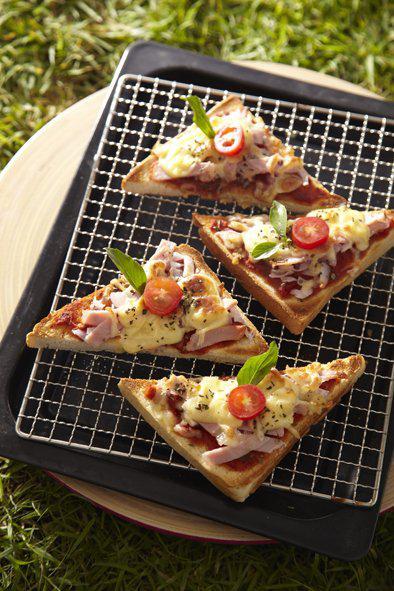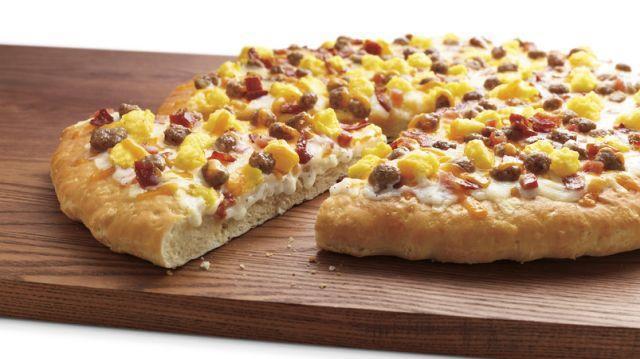The first image is the image on the left, the second image is the image on the right. Evaluate the accuracy of this statement regarding the images: "There is at least one uncut pizza.". Is it true? Answer yes or no. No. The first image is the image on the left, the second image is the image on the right. Analyze the images presented: Is the assertion "All the pizzas in these images are still whole circles and have not yet been cut into slices." valid? Answer yes or no. No. 